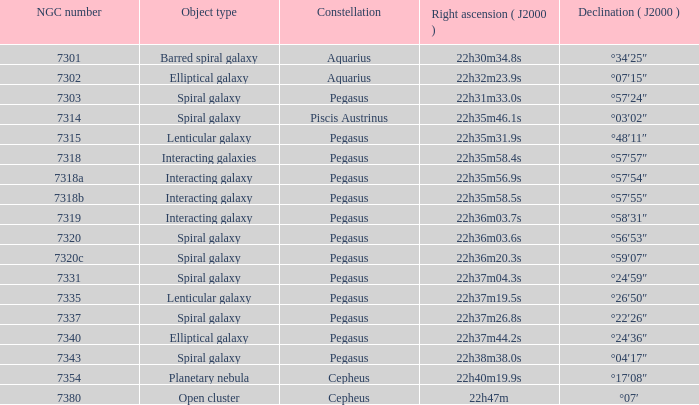What is the right ascension of Pegasus with a 7343 NGC? 22h38m38.0s. 